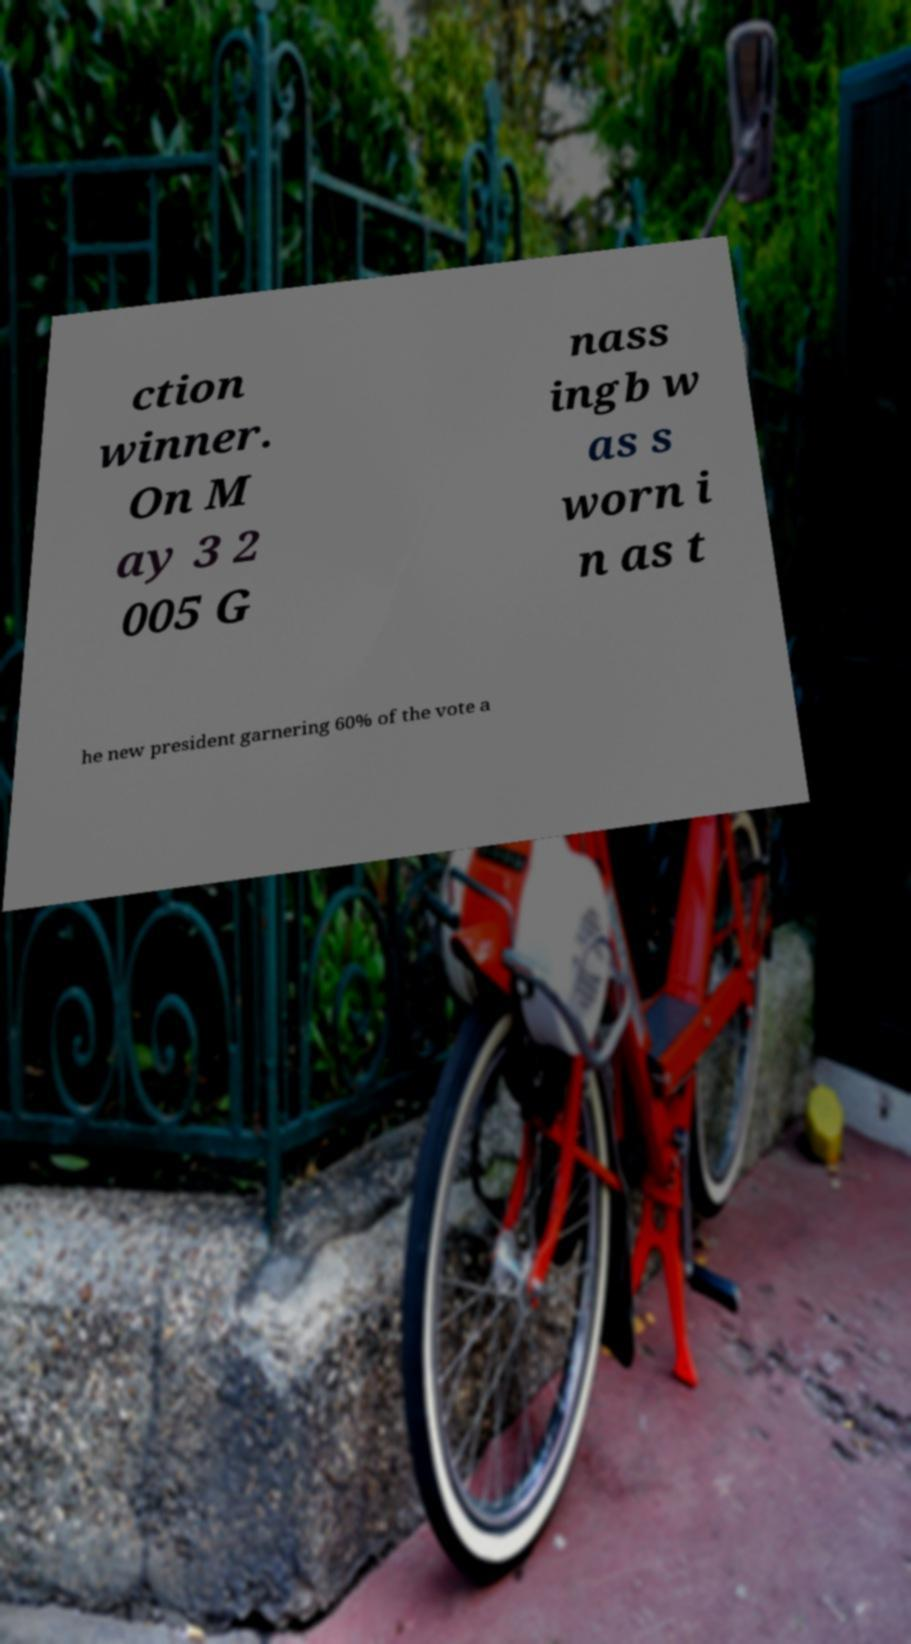Can you accurately transcribe the text from the provided image for me? ction winner. On M ay 3 2 005 G nass ingb w as s worn i n as t he new president garnering 60% of the vote a 